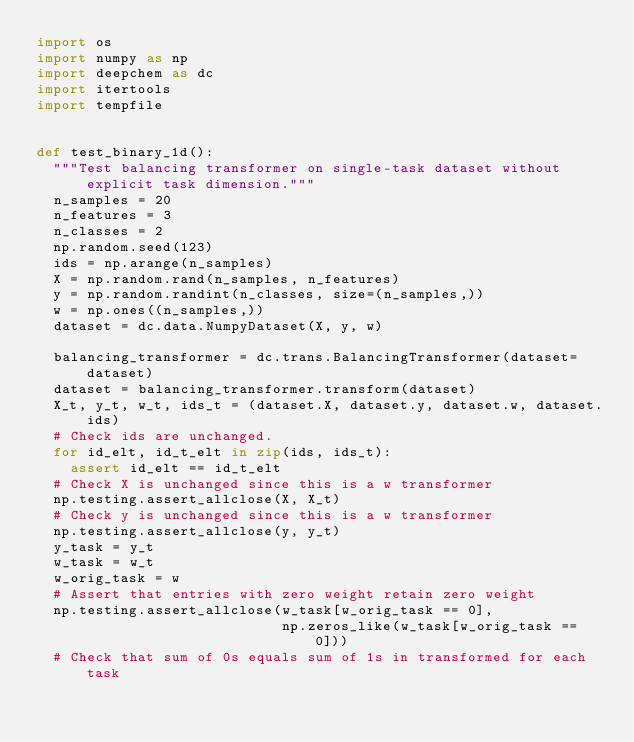Convert code to text. <code><loc_0><loc_0><loc_500><loc_500><_Python_>import os
import numpy as np
import deepchem as dc
import itertools
import tempfile


def test_binary_1d():
  """Test balancing transformer on single-task dataset without explicit task dimension."""
  n_samples = 20
  n_features = 3
  n_classes = 2
  np.random.seed(123)
  ids = np.arange(n_samples)
  X = np.random.rand(n_samples, n_features)
  y = np.random.randint(n_classes, size=(n_samples,))
  w = np.ones((n_samples,))
  dataset = dc.data.NumpyDataset(X, y, w)

  balancing_transformer = dc.trans.BalancingTransformer(dataset=dataset)
  dataset = balancing_transformer.transform(dataset)
  X_t, y_t, w_t, ids_t = (dataset.X, dataset.y, dataset.w, dataset.ids)
  # Check ids are unchanged.
  for id_elt, id_t_elt in zip(ids, ids_t):
    assert id_elt == id_t_elt
  # Check X is unchanged since this is a w transformer
  np.testing.assert_allclose(X, X_t)
  # Check y is unchanged since this is a w transformer
  np.testing.assert_allclose(y, y_t)
  y_task = y_t
  w_task = w_t
  w_orig_task = w
  # Assert that entries with zero weight retain zero weight
  np.testing.assert_allclose(w_task[w_orig_task == 0],
                             np.zeros_like(w_task[w_orig_task == 0]))
  # Check that sum of 0s equals sum of 1s in transformed for each task</code> 